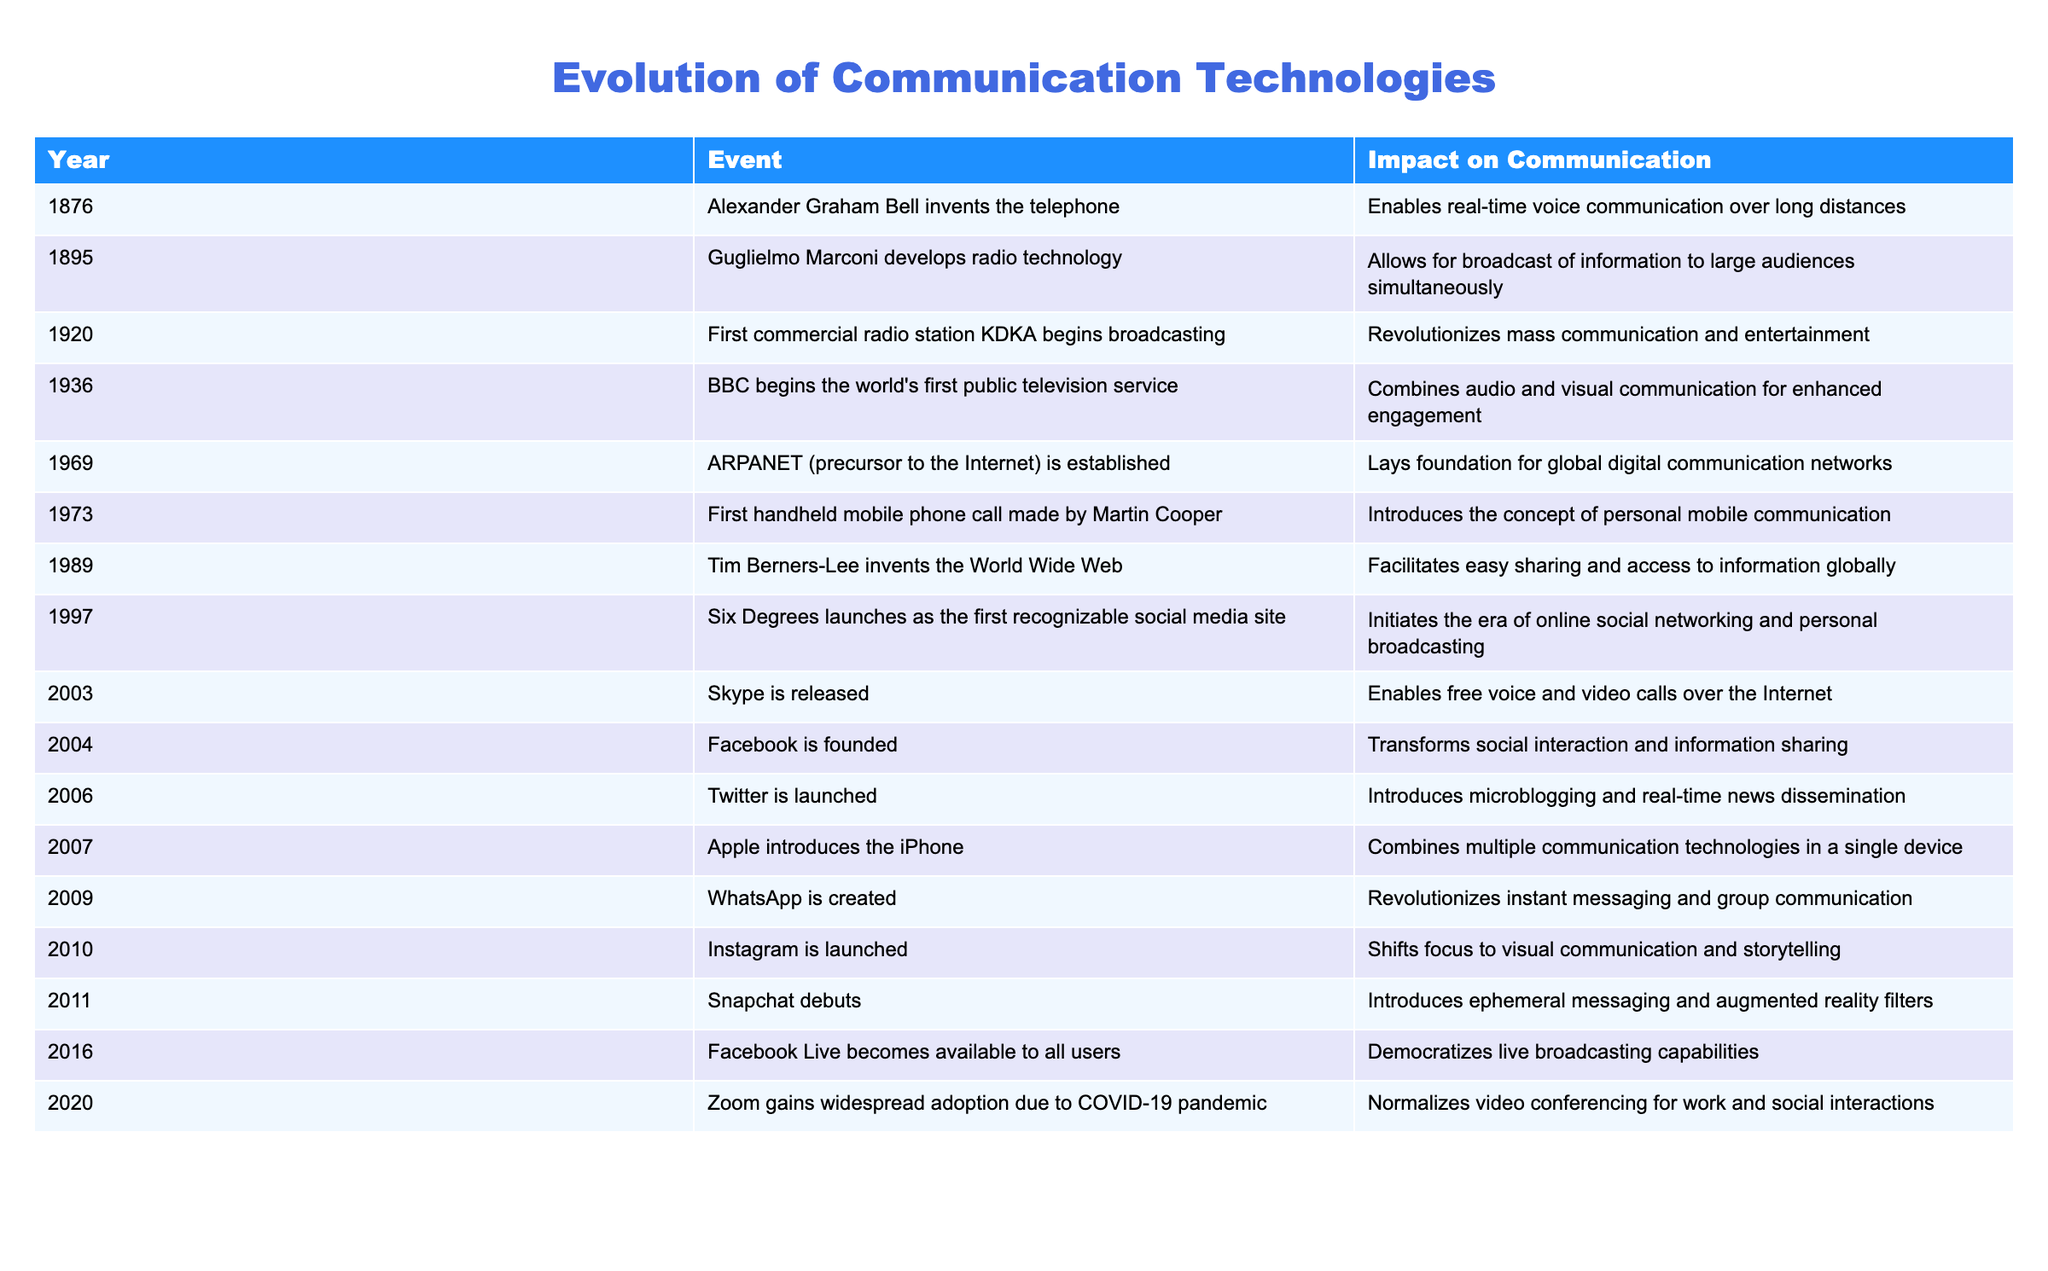What year was the telephone invented? The table lists the invention of the telephone in the year 1876 under the Events column, which corresponds to Alexander Graham Bell.
Answer: 1876 How many years passed between the invention of the telephone and the development of radio technology? The telephone was invented in 1876 and radio technology was developed in 1895. The difference between the two years is 1895 - 1876 = 19 years.
Answer: 19 years Does the invention of the World Wide Web facilitate access to information globally? The table states that the invention of the World Wide Web by Tim Berners-Lee in 1989 facilitates easy sharing and access to information globally, indicating that this is true.
Answer: Yes Which technology was the first to combine audio and visual communication? The table shows that BBC began the world's first public television service in 1936, which combined audio and visual communication.
Answer: BBC television service in 1936 How many significant communication technologies were introduced between 1900 and 1950? From the table, the significant technologies introduced in this period are radio (1895), KDKA station (1920), and BBC television service (1936). That totals three significant technologies.
Answer: 3 technologies In what year was the first social media site launched? According to the table, Six Degrees was launched in 1997 as the first recognizable social media site.
Answer: 1997 What impact did the introduction of the iPhone in 2007 have on communication? The table states that the introduction of the iPhone combined multiple communication technologies in a single device, signifying a major advancement in personal communication technology.
Answer: Combined multiple technologies Which event laid the foundation for global digital communication networks? The table indicates that the establishment of ARPANET in 1969 laid the foundation for global digital communication networks.
Answer: ARPANET in 1969 How many years are there between the launch of Facebook and the launch of Twitter? Facebook was founded in 2004 and Twitter was launched in 2006. The difference between these years is 2006 - 2004 = 2 years.
Answer: 2 years 